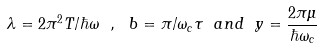Convert formula to latex. <formula><loc_0><loc_0><loc_500><loc_500>\lambda = 2 \pi ^ { 2 } T / \hbar { \omega } \ , \ b = \pi / \omega _ { c } \tau \ a n d \ y = \frac { 2 \pi \mu } { \hbar { \omega } _ { c } }</formula> 